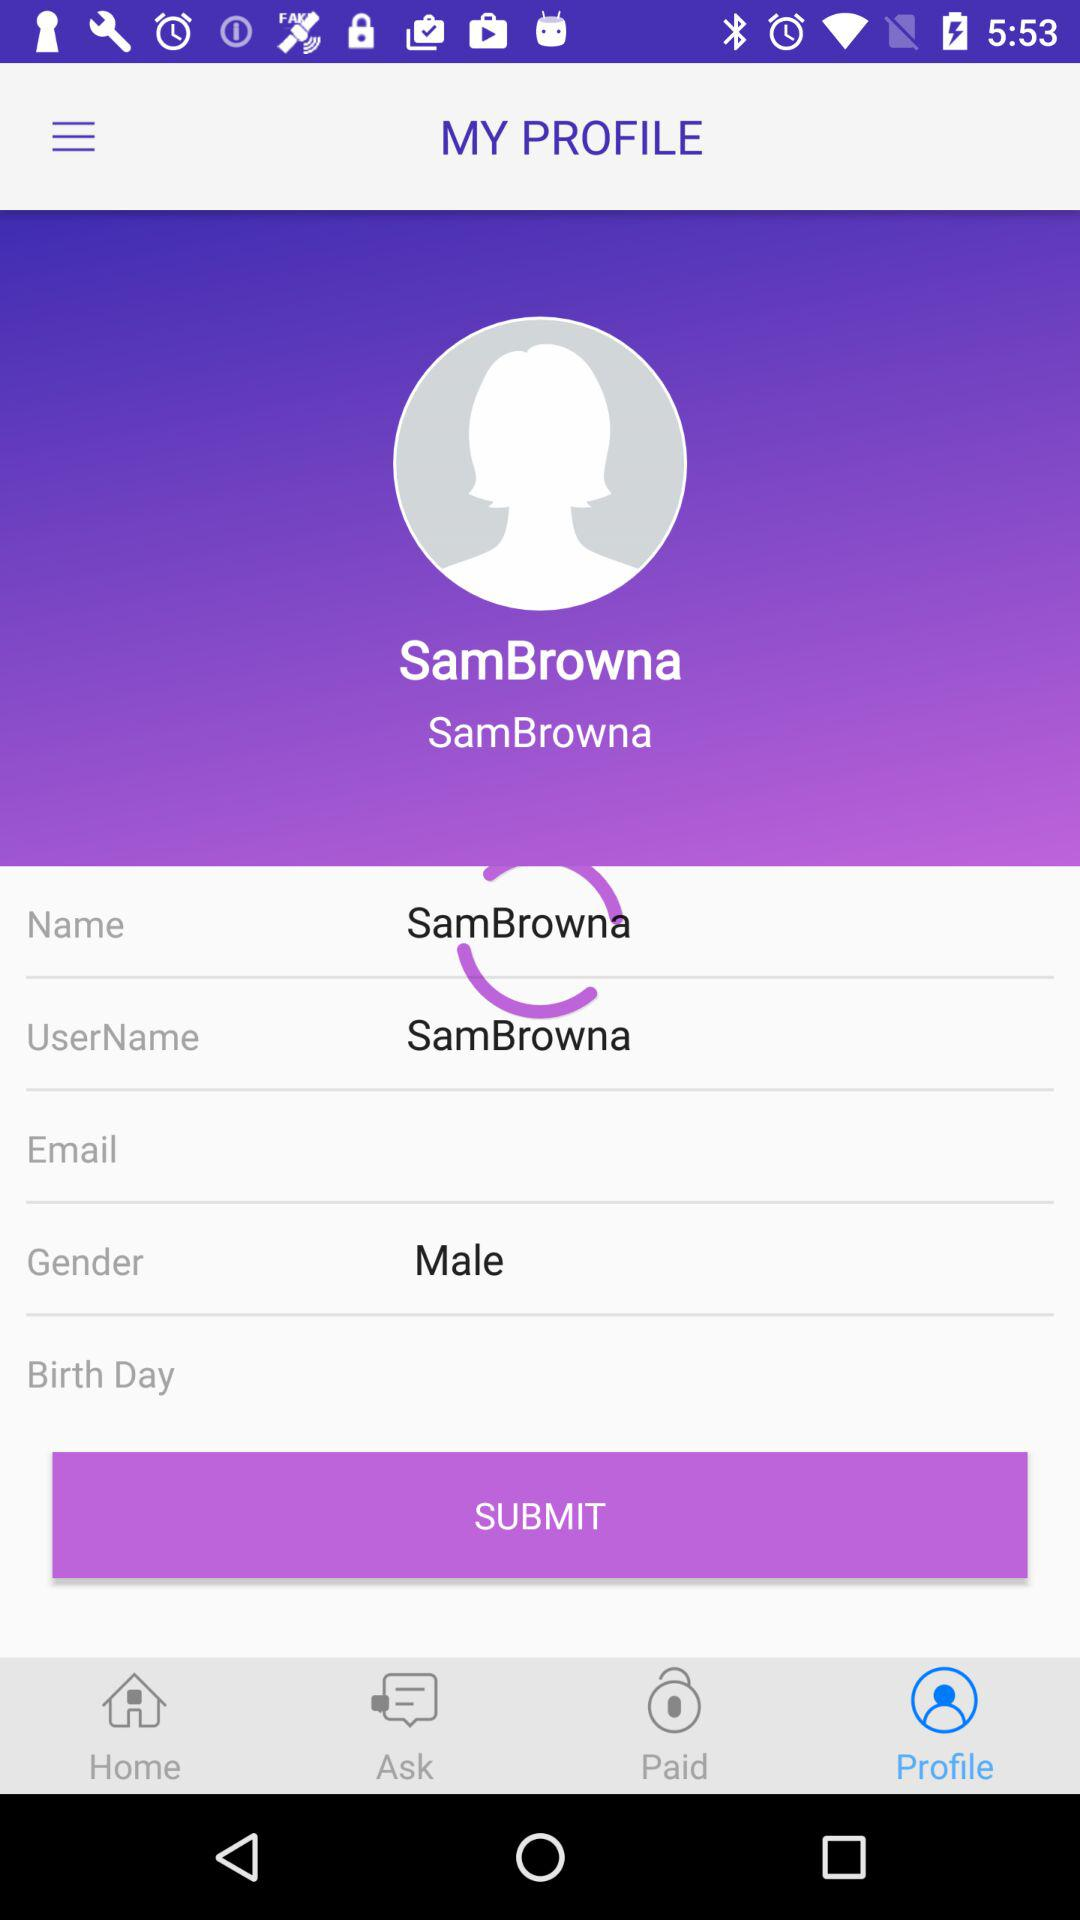Which tab has been selected? The selected tab is "Profile". 